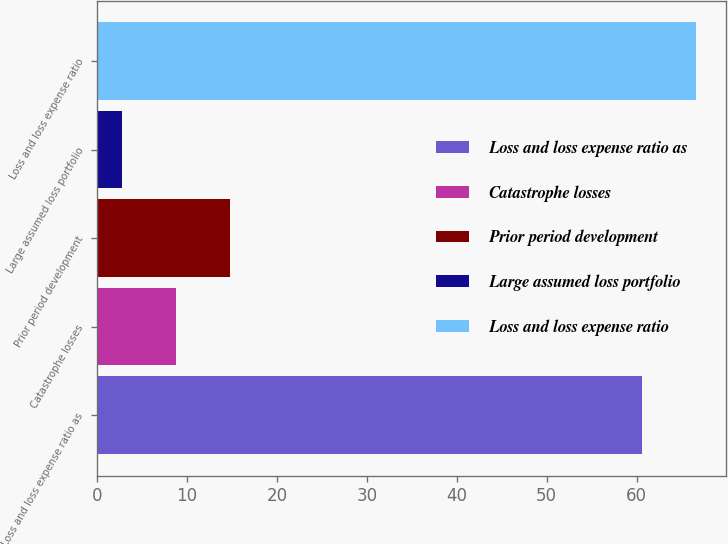<chart> <loc_0><loc_0><loc_500><loc_500><bar_chart><fcel>Loss and loss expense ratio as<fcel>Catastrophe losses<fcel>Prior period development<fcel>Large assumed loss portfolio<fcel>Loss and loss expense ratio<nl><fcel>60.6<fcel>8.75<fcel>14.74<fcel>2.76<fcel>66.59<nl></chart> 